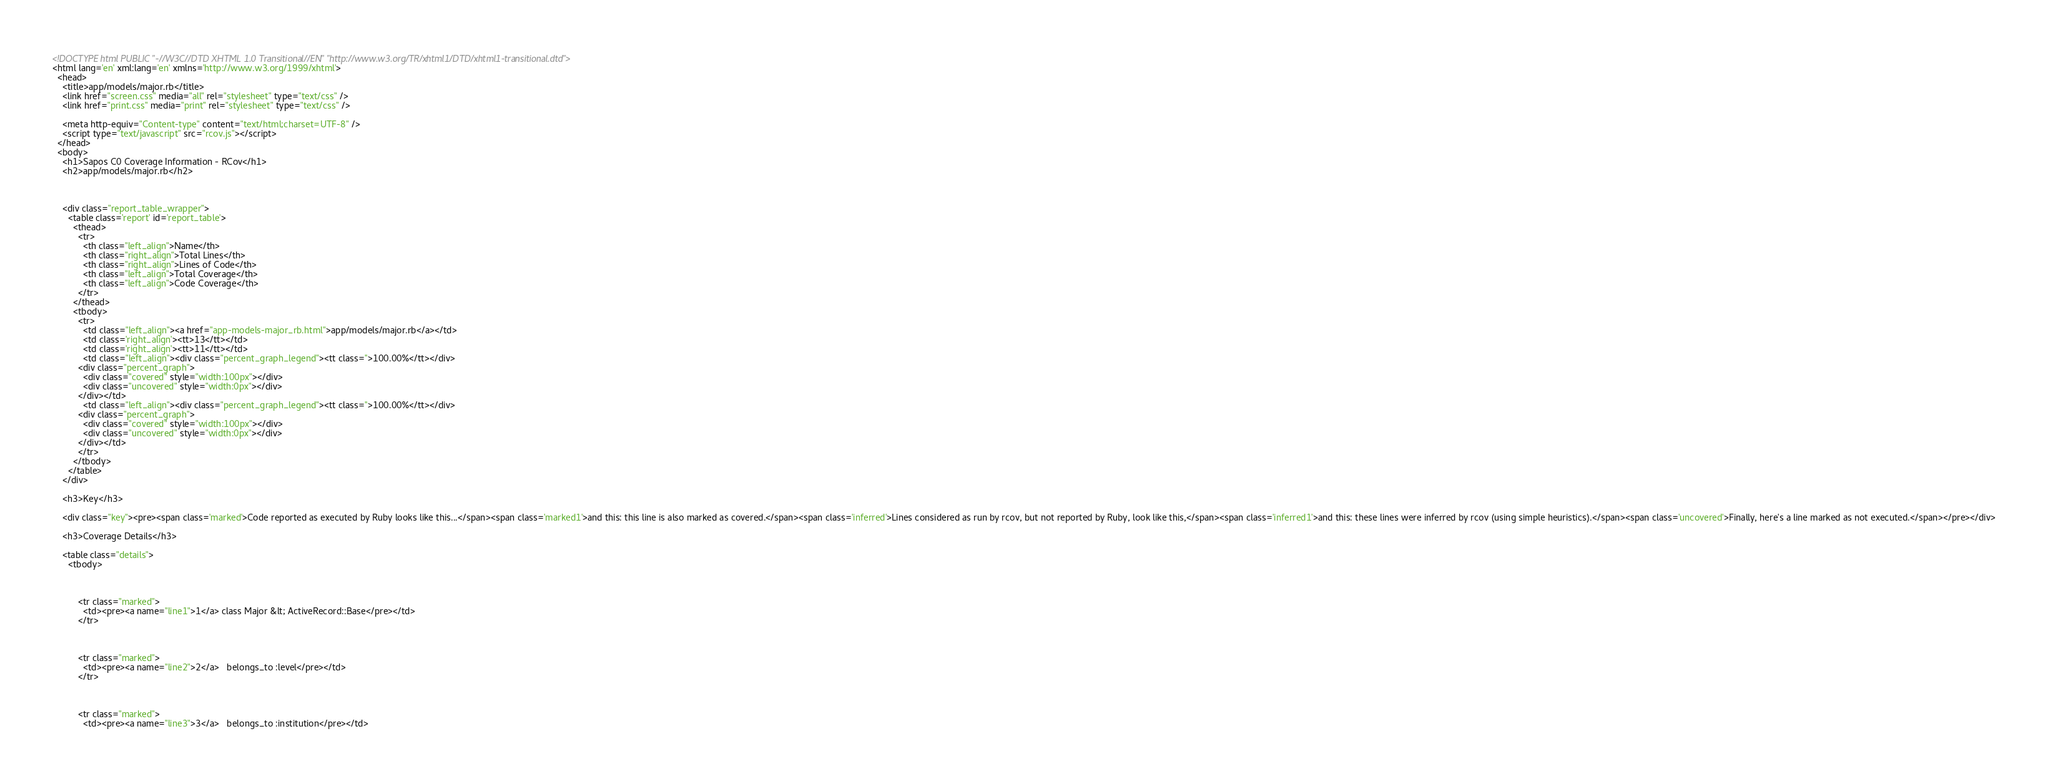<code> <loc_0><loc_0><loc_500><loc_500><_HTML_><!DOCTYPE html PUBLIC "-//W3C//DTD XHTML 1.0 Transitional//EN" "http://www.w3.org/TR/xhtml1/DTD/xhtml1-transitional.dtd">
<html lang='en' xml:lang='en' xmlns='http://www.w3.org/1999/xhtml'>
  <head>
    <title>app/models/major.rb</title>
    <link href="screen.css" media="all" rel="stylesheet" type="text/css" />
    <link href="print.css" media="print" rel="stylesheet" type="text/css" />
    
    <meta http-equiv="Content-type" content="text/html;charset=UTF-8" />
    <script type="text/javascript" src="rcov.js"></script>
  </head>
  <body>
    <h1>Sapos C0 Coverage Information - RCov</h1>
    <h2>app/models/major.rb</h2>

    

    <div class="report_table_wrapper">
      <table class='report' id='report_table'>
        <thead>
          <tr>
            <th class="left_align">Name</th>
            <th class="right_align">Total Lines</th>
            <th class="right_align">Lines of Code</th>
            <th class="left_align">Total Coverage</th>
            <th class="left_align">Code Coverage</th>
          </tr>
        </thead>
        <tbody>
          <tr>
            <td class="left_align"><a href="app-models-major_rb.html">app/models/major.rb</a></td>
            <td class='right_align'><tt>13</tt></td>
            <td class='right_align'><tt>11</tt></td>
            <td class="left_align"><div class="percent_graph_legend"><tt class=''>100.00%</tt></div>
          <div class="percent_graph">
            <div class="covered" style="width:100px"></div>
            <div class="uncovered" style="width:0px"></div>
          </div></td>
            <td class="left_align"><div class="percent_graph_legend"><tt class=''>100.00%</tt></div>
          <div class="percent_graph">
            <div class="covered" style="width:100px"></div>
            <div class="uncovered" style="width:0px"></div>
          </div></td>
          </tr>
        </tbody>
      </table>
    </div>
    
    <h3>Key</h3>
    
    <div class="key"><pre><span class='marked'>Code reported as executed by Ruby looks like this...</span><span class='marked1'>and this: this line is also marked as covered.</span><span class='inferred'>Lines considered as run by rcov, but not reported by Ruby, look like this,</span><span class='inferred1'>and this: these lines were inferred by rcov (using simple heuristics).</span><span class='uncovered'>Finally, here's a line marked as not executed.</span></pre></div>

    <h3>Coverage Details</h3>

    <table class="details">
      <tbody>
        
          
          
          <tr class="marked">
            <td><pre><a name="line1">1</a> class Major &lt; ActiveRecord::Base</pre></td>
          </tr>
        
          
          
          <tr class="marked">
            <td><pre><a name="line2">2</a>   belongs_to :level</pre></td>
          </tr>
        
          
          
          <tr class="marked">
            <td><pre><a name="line3">3</a>   belongs_to :institution</pre></td></code> 